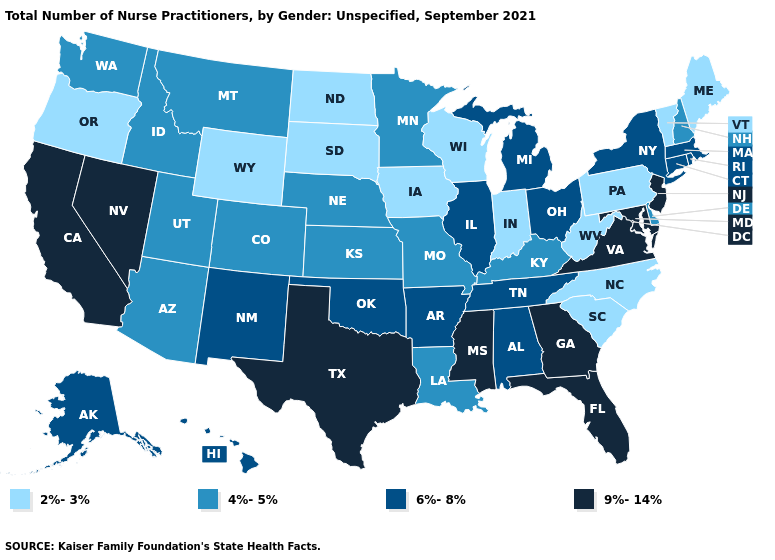Among the states that border West Virginia , which have the highest value?
Write a very short answer. Maryland, Virginia. What is the value of Delaware?
Write a very short answer. 4%-5%. What is the value of Kentucky?
Answer briefly. 4%-5%. What is the value of Oklahoma?
Be succinct. 6%-8%. What is the value of Florida?
Short answer required. 9%-14%. Name the states that have a value in the range 9%-14%?
Short answer required. California, Florida, Georgia, Maryland, Mississippi, Nevada, New Jersey, Texas, Virginia. What is the value of Tennessee?
Write a very short answer. 6%-8%. Which states have the highest value in the USA?
Write a very short answer. California, Florida, Georgia, Maryland, Mississippi, Nevada, New Jersey, Texas, Virginia. What is the lowest value in the USA?
Concise answer only. 2%-3%. What is the value of Montana?
Write a very short answer. 4%-5%. What is the value of Texas?
Quick response, please. 9%-14%. Does New Jersey have the highest value in the Northeast?
Be succinct. Yes. What is the lowest value in the South?
Answer briefly. 2%-3%. What is the value of Maine?
Be succinct. 2%-3%. Does Delaware have a lower value than Rhode Island?
Keep it brief. Yes. 